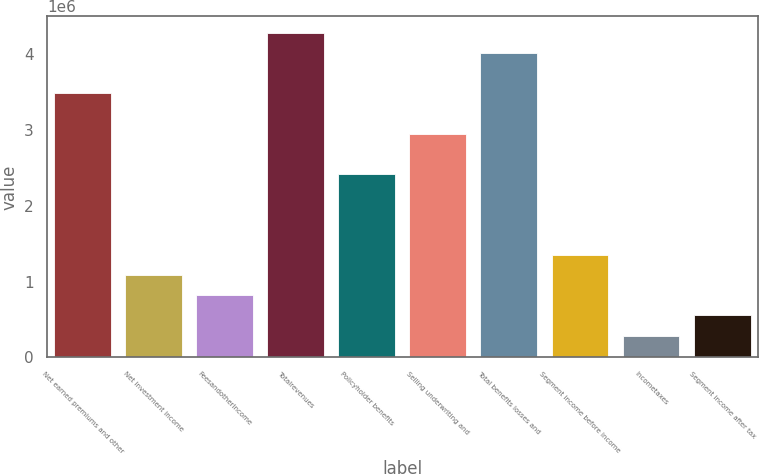<chart> <loc_0><loc_0><loc_500><loc_500><bar_chart><fcel>Net earned premiums and other<fcel>Net investment income<fcel>Feesandotherincome<fcel>Totalrevenues<fcel>Policyholder benefits<fcel>Selling underwriting and<fcel>Total benefits losses and<fcel>Segment income before income<fcel>Incometaxes<fcel>Segment income after tax<nl><fcel>3.48791e+06<fcel>1.08864e+06<fcel>822057<fcel>4.28766e+06<fcel>2.42157e+06<fcel>2.95474e+06<fcel>4.02108e+06<fcel>1.35523e+06<fcel>288887<fcel>555472<nl></chart> 